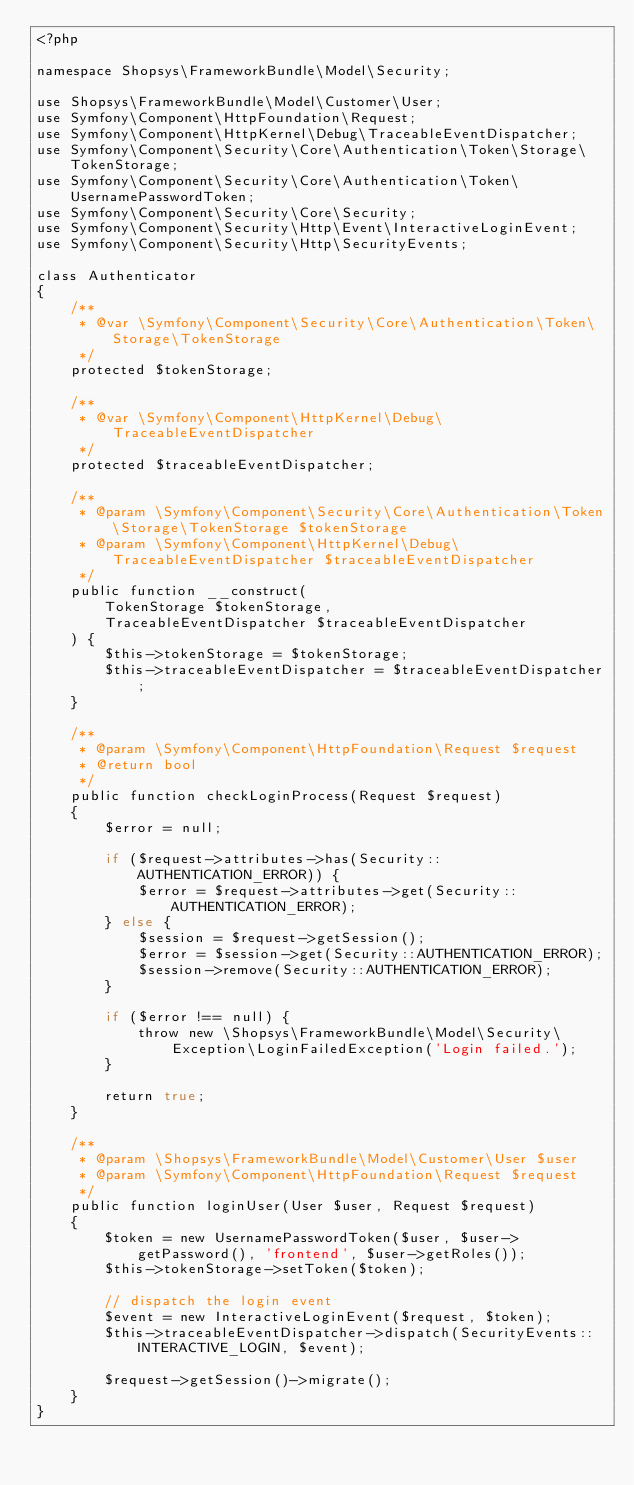Convert code to text. <code><loc_0><loc_0><loc_500><loc_500><_PHP_><?php

namespace Shopsys\FrameworkBundle\Model\Security;

use Shopsys\FrameworkBundle\Model\Customer\User;
use Symfony\Component\HttpFoundation\Request;
use Symfony\Component\HttpKernel\Debug\TraceableEventDispatcher;
use Symfony\Component\Security\Core\Authentication\Token\Storage\TokenStorage;
use Symfony\Component\Security\Core\Authentication\Token\UsernamePasswordToken;
use Symfony\Component\Security\Core\Security;
use Symfony\Component\Security\Http\Event\InteractiveLoginEvent;
use Symfony\Component\Security\Http\SecurityEvents;

class Authenticator
{
    /**
     * @var \Symfony\Component\Security\Core\Authentication\Token\Storage\TokenStorage
     */
    protected $tokenStorage;

    /**
     * @var \Symfony\Component\HttpKernel\Debug\TraceableEventDispatcher
     */
    protected $traceableEventDispatcher;

    /**
     * @param \Symfony\Component\Security\Core\Authentication\Token\Storage\TokenStorage $tokenStorage
     * @param \Symfony\Component\HttpKernel\Debug\TraceableEventDispatcher $traceableEventDispatcher
     */
    public function __construct(
        TokenStorage $tokenStorage,
        TraceableEventDispatcher $traceableEventDispatcher
    ) {
        $this->tokenStorage = $tokenStorage;
        $this->traceableEventDispatcher = $traceableEventDispatcher;
    }

    /**
     * @param \Symfony\Component\HttpFoundation\Request $request
     * @return bool
     */
    public function checkLoginProcess(Request $request)
    {
        $error = null;

        if ($request->attributes->has(Security::AUTHENTICATION_ERROR)) {
            $error = $request->attributes->get(Security::AUTHENTICATION_ERROR);
        } else {
            $session = $request->getSession();
            $error = $session->get(Security::AUTHENTICATION_ERROR);
            $session->remove(Security::AUTHENTICATION_ERROR);
        }

        if ($error !== null) {
            throw new \Shopsys\FrameworkBundle\Model\Security\Exception\LoginFailedException('Login failed.');
        }

        return true;
    }

    /**
     * @param \Shopsys\FrameworkBundle\Model\Customer\User $user
     * @param \Symfony\Component\HttpFoundation\Request $request
     */
    public function loginUser(User $user, Request $request)
    {
        $token = new UsernamePasswordToken($user, $user->getPassword(), 'frontend', $user->getRoles());
        $this->tokenStorage->setToken($token);

        // dispatch the login event
        $event = new InteractiveLoginEvent($request, $token);
        $this->traceableEventDispatcher->dispatch(SecurityEvents::INTERACTIVE_LOGIN, $event);

        $request->getSession()->migrate();
    }
}
</code> 